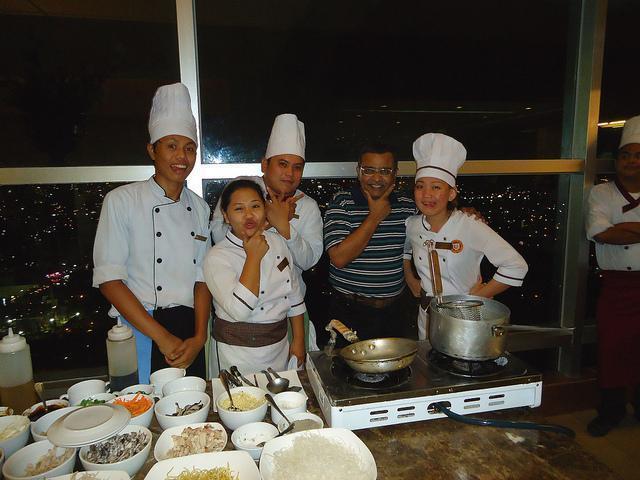How many people are wearing hats?
Give a very brief answer. 4. How many bowls are there?
Give a very brief answer. 3. How many people can be seen?
Give a very brief answer. 6. 